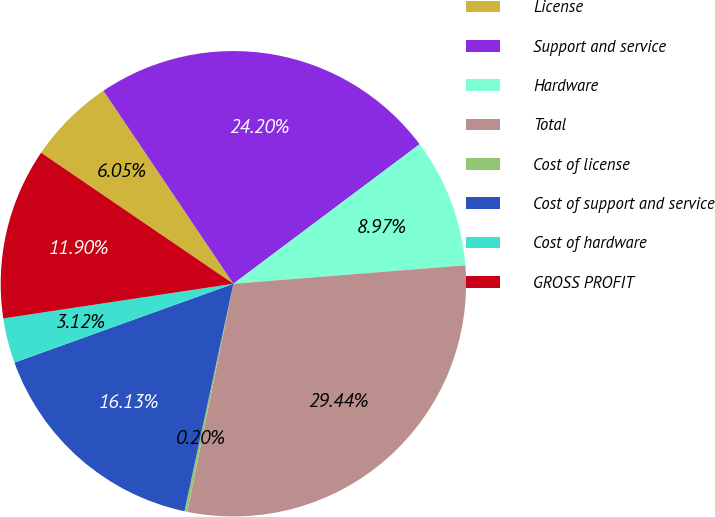<chart> <loc_0><loc_0><loc_500><loc_500><pie_chart><fcel>License<fcel>Support and service<fcel>Hardware<fcel>Total<fcel>Cost of license<fcel>Cost of support and service<fcel>Cost of hardware<fcel>GROSS PROFIT<nl><fcel>6.05%<fcel>24.2%<fcel>8.97%<fcel>29.44%<fcel>0.2%<fcel>16.13%<fcel>3.12%<fcel>11.9%<nl></chart> 